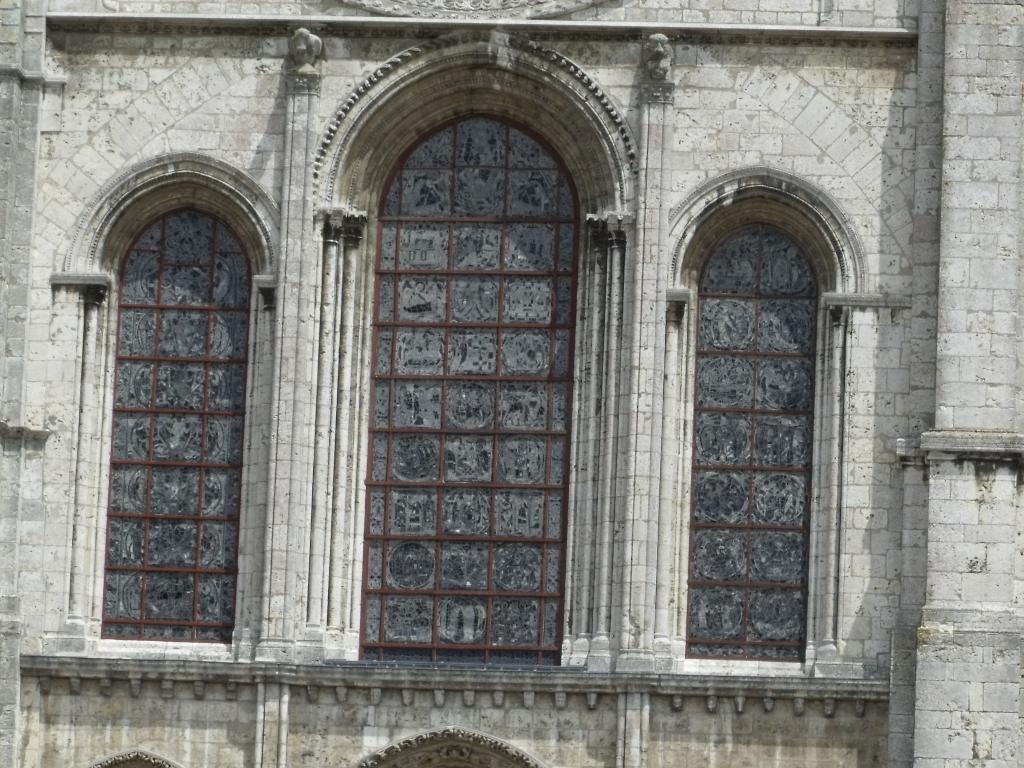What type of structure can be seen in the image? There are walls in the image. What type of objects are made of glass in the image? There are glass objects in the image. What type of decorative elements are present in the image? There are carvings in the image. Can you describe the hair on the bee in the image? There is no bee present in the image, and therefore no hair to describe. 